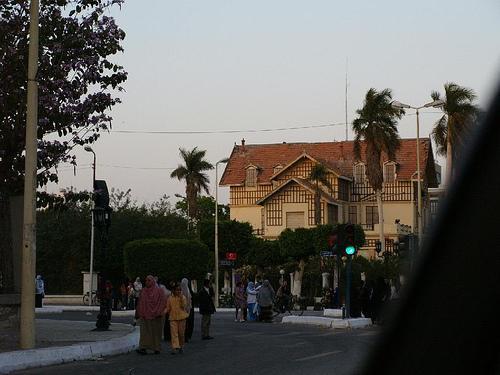How many people holding hands?
Give a very brief answer. 2. 